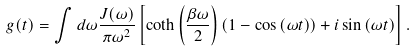Convert formula to latex. <formula><loc_0><loc_0><loc_500><loc_500>g ( t ) = \int d \omega \frac { J ( \omega ) } { \pi \omega ^ { 2 } } \left [ \coth \left ( \frac { \beta \omega } { 2 } \right ) \left ( 1 - \cos \left ( \omega t \right ) \right ) + i \sin \left ( \omega t \right ) \right ] .</formula> 